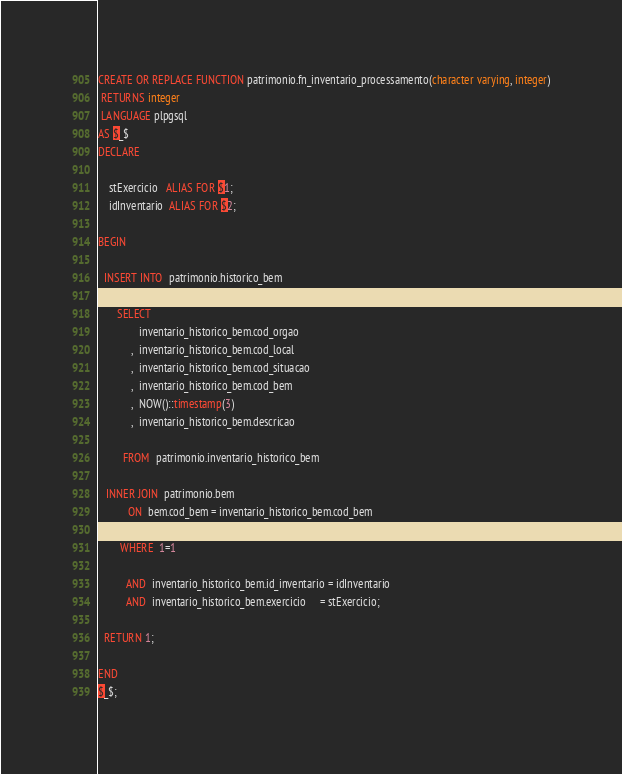<code> <loc_0><loc_0><loc_500><loc_500><_SQL_>CREATE OR REPLACE FUNCTION patrimonio.fn_inventario_processamento(character varying, integer)
 RETURNS integer
 LANGUAGE plpgsql
AS $_$
DECLARE

    stExercicio   ALIAS FOR $1;
    idInventario  ALIAS FOR $2;

BEGIN

  INSERT INTO  patrimonio.historico_bem
  
       SELECT
               inventario_historico_bem.cod_orgao
            ,  inventario_historico_bem.cod_local
            ,  inventario_historico_bem.cod_situacao
            ,  inventario_historico_bem.cod_bem
            ,  NOW()::timestamp(3)
            ,  inventario_historico_bem.descricao
            
         FROM  patrimonio.inventario_historico_bem
         
   INNER JOIN  patrimonio.bem
           ON  bem.cod_bem = inventario_historico_bem.cod_bem
   
        WHERE  1=1
  
          AND  inventario_historico_bem.id_inventario = idInventario
          AND  inventario_historico_bem.exercicio     = stExercicio;

  RETURN 1;
 
END
$_$;
</code> 